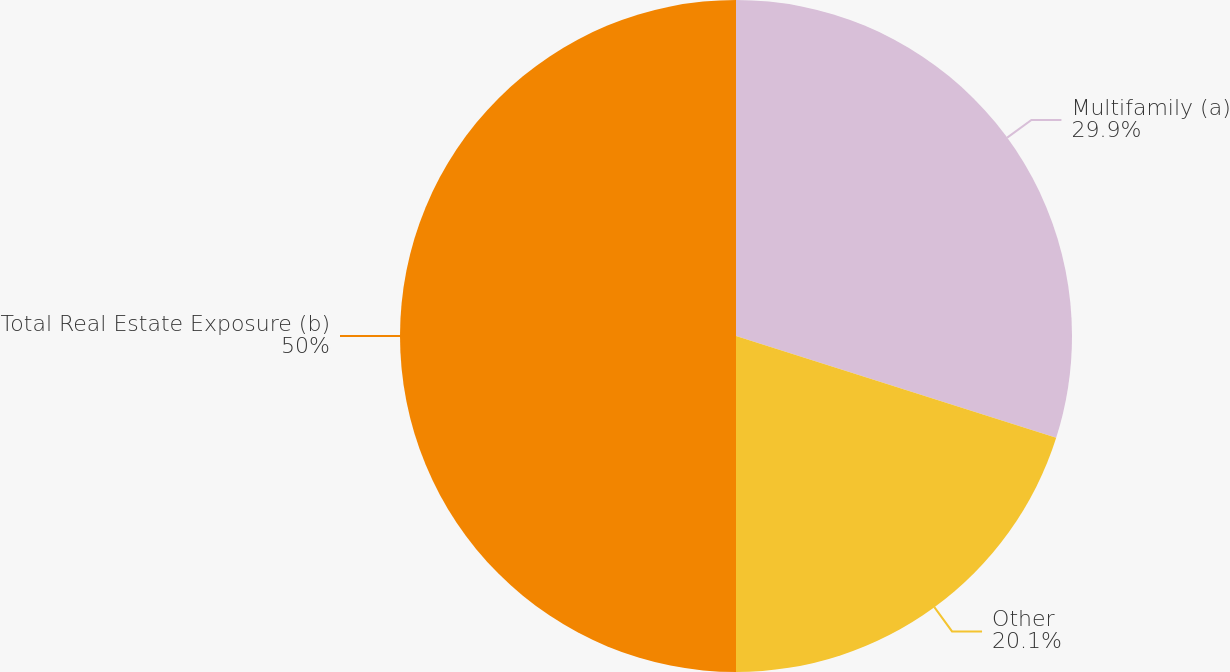<chart> <loc_0><loc_0><loc_500><loc_500><pie_chart><fcel>Multifamily (a)<fcel>Other<fcel>Total Real Estate Exposure (b)<nl><fcel>29.9%<fcel>20.1%<fcel>50.0%<nl></chart> 